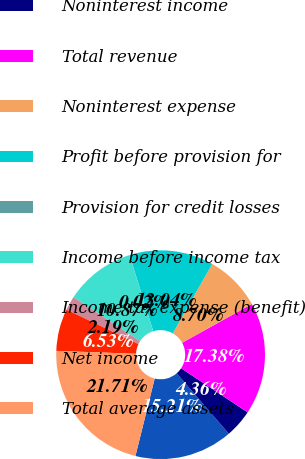<chart> <loc_0><loc_0><loc_500><loc_500><pie_chart><fcel>Net interest income<fcel>Noninterest income<fcel>Total revenue<fcel>Noninterest expense<fcel>Profit before provision for<fcel>Provision for credit losses<fcel>Income before income tax<fcel>Income tax expense (benefit)<fcel>Net income<fcel>Total average assets<nl><fcel>15.21%<fcel>4.36%<fcel>17.38%<fcel>8.7%<fcel>13.04%<fcel>0.02%<fcel>10.87%<fcel>2.19%<fcel>6.53%<fcel>21.71%<nl></chart> 